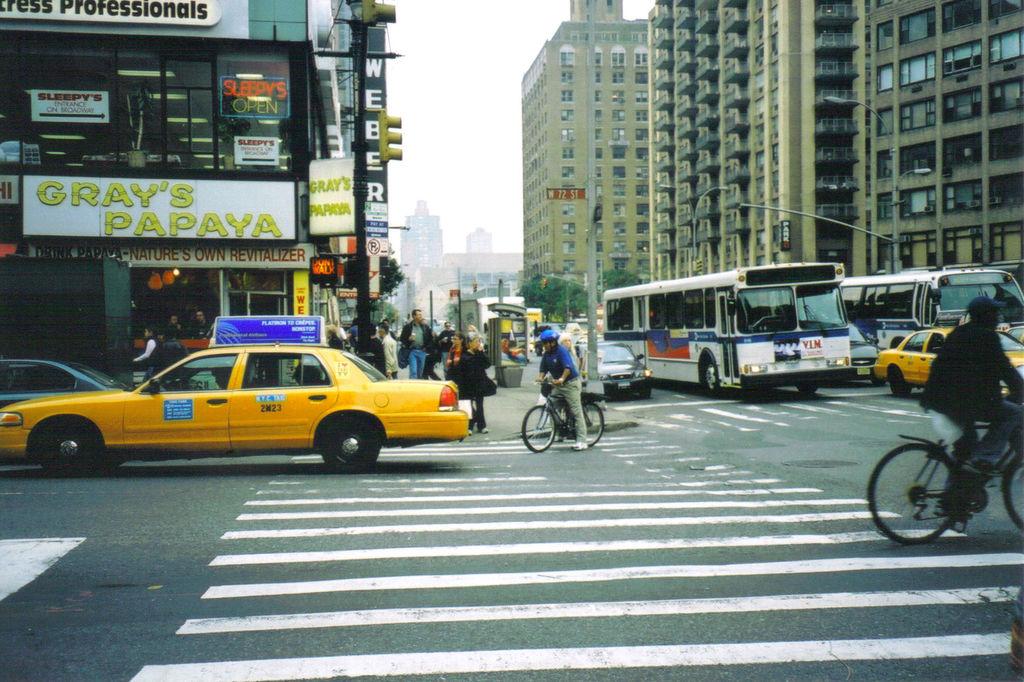Whos papaya is it?
Make the answer very short. Gray's. What does the big white and black sing on top say?
Provide a succinct answer. Professionals. 